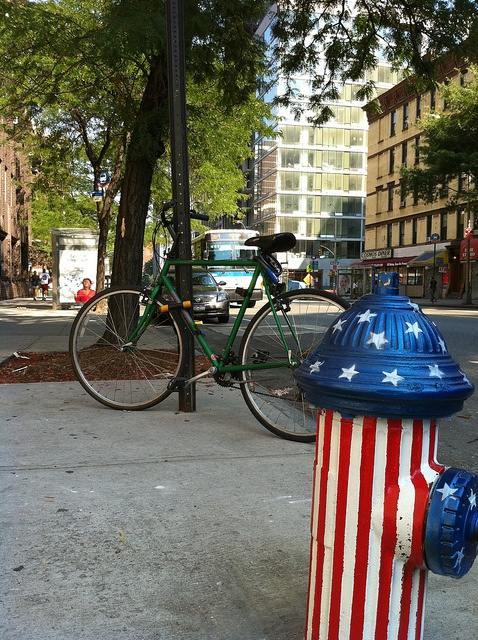Describe the objects in this image and their specific colors. I can see fire hydrant in darkgreen, brown, black, navy, and lightgray tones, bicycle in darkgreen, black, and gray tones, bus in darkgreen, white, black, gray, and darkgray tones, car in darkgreen, black, gray, darkgray, and white tones, and people in darkgreen, salmon, ivory, red, and brown tones in this image. 